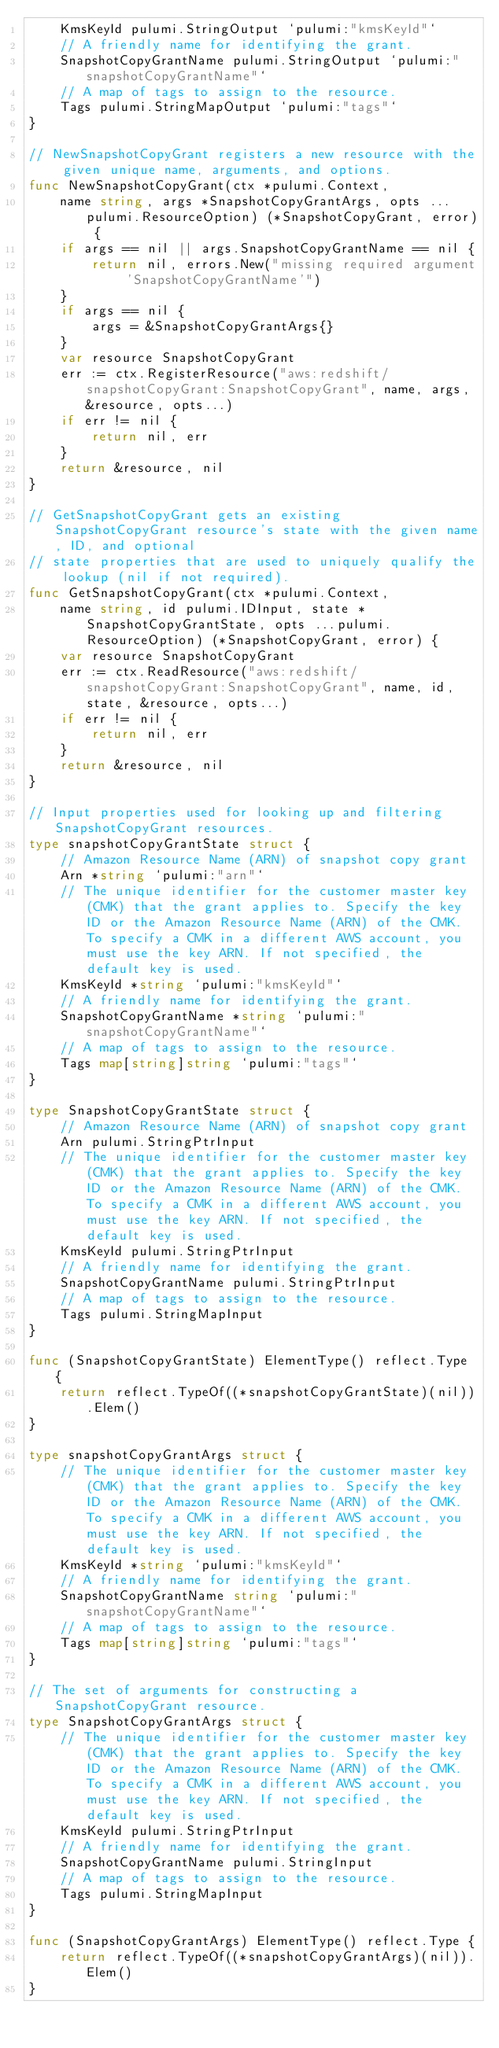Convert code to text. <code><loc_0><loc_0><loc_500><loc_500><_Go_>	KmsKeyId pulumi.StringOutput `pulumi:"kmsKeyId"`
	// A friendly name for identifying the grant.
	SnapshotCopyGrantName pulumi.StringOutput `pulumi:"snapshotCopyGrantName"`
	// A map of tags to assign to the resource.
	Tags pulumi.StringMapOutput `pulumi:"tags"`
}

// NewSnapshotCopyGrant registers a new resource with the given unique name, arguments, and options.
func NewSnapshotCopyGrant(ctx *pulumi.Context,
	name string, args *SnapshotCopyGrantArgs, opts ...pulumi.ResourceOption) (*SnapshotCopyGrant, error) {
	if args == nil || args.SnapshotCopyGrantName == nil {
		return nil, errors.New("missing required argument 'SnapshotCopyGrantName'")
	}
	if args == nil {
		args = &SnapshotCopyGrantArgs{}
	}
	var resource SnapshotCopyGrant
	err := ctx.RegisterResource("aws:redshift/snapshotCopyGrant:SnapshotCopyGrant", name, args, &resource, opts...)
	if err != nil {
		return nil, err
	}
	return &resource, nil
}

// GetSnapshotCopyGrant gets an existing SnapshotCopyGrant resource's state with the given name, ID, and optional
// state properties that are used to uniquely qualify the lookup (nil if not required).
func GetSnapshotCopyGrant(ctx *pulumi.Context,
	name string, id pulumi.IDInput, state *SnapshotCopyGrantState, opts ...pulumi.ResourceOption) (*SnapshotCopyGrant, error) {
	var resource SnapshotCopyGrant
	err := ctx.ReadResource("aws:redshift/snapshotCopyGrant:SnapshotCopyGrant", name, id, state, &resource, opts...)
	if err != nil {
		return nil, err
	}
	return &resource, nil
}

// Input properties used for looking up and filtering SnapshotCopyGrant resources.
type snapshotCopyGrantState struct {
	// Amazon Resource Name (ARN) of snapshot copy grant
	Arn *string `pulumi:"arn"`
	// The unique identifier for the customer master key (CMK) that the grant applies to. Specify the key ID or the Amazon Resource Name (ARN) of the CMK. To specify a CMK in a different AWS account, you must use the key ARN. If not specified, the default key is used.
	KmsKeyId *string `pulumi:"kmsKeyId"`
	// A friendly name for identifying the grant.
	SnapshotCopyGrantName *string `pulumi:"snapshotCopyGrantName"`
	// A map of tags to assign to the resource.
	Tags map[string]string `pulumi:"tags"`
}

type SnapshotCopyGrantState struct {
	// Amazon Resource Name (ARN) of snapshot copy grant
	Arn pulumi.StringPtrInput
	// The unique identifier for the customer master key (CMK) that the grant applies to. Specify the key ID or the Amazon Resource Name (ARN) of the CMK. To specify a CMK in a different AWS account, you must use the key ARN. If not specified, the default key is used.
	KmsKeyId pulumi.StringPtrInput
	// A friendly name for identifying the grant.
	SnapshotCopyGrantName pulumi.StringPtrInput
	// A map of tags to assign to the resource.
	Tags pulumi.StringMapInput
}

func (SnapshotCopyGrantState) ElementType() reflect.Type {
	return reflect.TypeOf((*snapshotCopyGrantState)(nil)).Elem()
}

type snapshotCopyGrantArgs struct {
	// The unique identifier for the customer master key (CMK) that the grant applies to. Specify the key ID or the Amazon Resource Name (ARN) of the CMK. To specify a CMK in a different AWS account, you must use the key ARN. If not specified, the default key is used.
	KmsKeyId *string `pulumi:"kmsKeyId"`
	// A friendly name for identifying the grant.
	SnapshotCopyGrantName string `pulumi:"snapshotCopyGrantName"`
	// A map of tags to assign to the resource.
	Tags map[string]string `pulumi:"tags"`
}

// The set of arguments for constructing a SnapshotCopyGrant resource.
type SnapshotCopyGrantArgs struct {
	// The unique identifier for the customer master key (CMK) that the grant applies to. Specify the key ID or the Amazon Resource Name (ARN) of the CMK. To specify a CMK in a different AWS account, you must use the key ARN. If not specified, the default key is used.
	KmsKeyId pulumi.StringPtrInput
	// A friendly name for identifying the grant.
	SnapshotCopyGrantName pulumi.StringInput
	// A map of tags to assign to the resource.
	Tags pulumi.StringMapInput
}

func (SnapshotCopyGrantArgs) ElementType() reflect.Type {
	return reflect.TypeOf((*snapshotCopyGrantArgs)(nil)).Elem()
}
</code> 